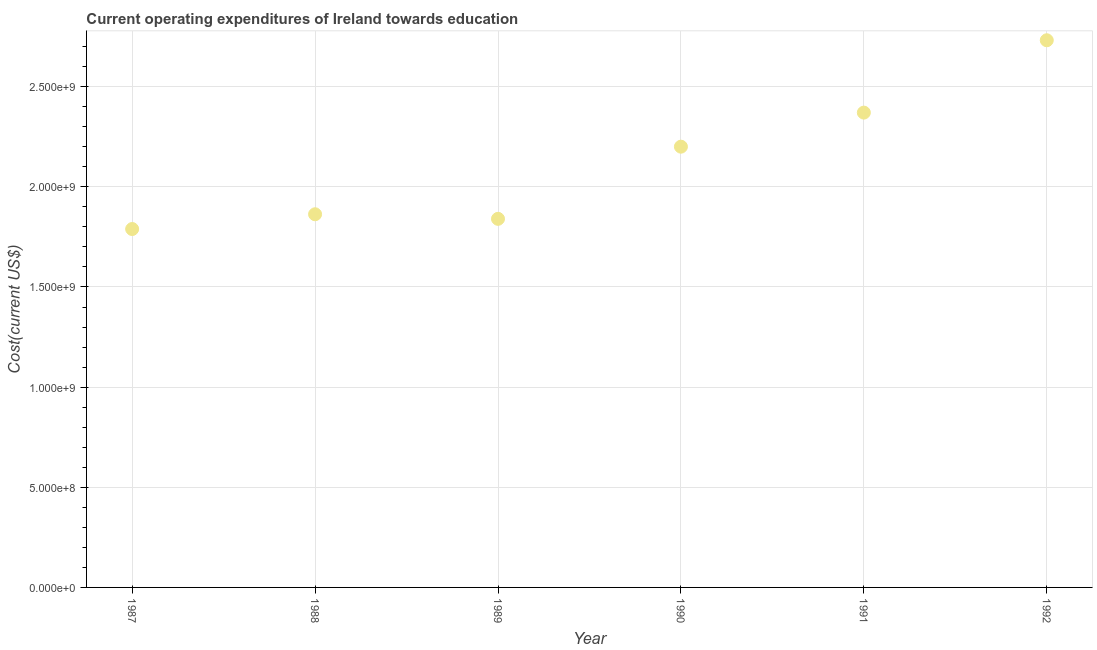What is the education expenditure in 1991?
Your response must be concise. 2.37e+09. Across all years, what is the maximum education expenditure?
Your response must be concise. 2.73e+09. Across all years, what is the minimum education expenditure?
Ensure brevity in your answer.  1.79e+09. In which year was the education expenditure maximum?
Your response must be concise. 1992. What is the sum of the education expenditure?
Ensure brevity in your answer.  1.28e+1. What is the difference between the education expenditure in 1989 and 1991?
Provide a short and direct response. -5.30e+08. What is the average education expenditure per year?
Make the answer very short. 2.13e+09. What is the median education expenditure?
Provide a short and direct response. 2.03e+09. In how many years, is the education expenditure greater than 600000000 US$?
Offer a terse response. 6. What is the ratio of the education expenditure in 1988 to that in 1989?
Offer a very short reply. 1.01. Is the education expenditure in 1991 less than that in 1992?
Your response must be concise. Yes. What is the difference between the highest and the second highest education expenditure?
Provide a short and direct response. 3.61e+08. Is the sum of the education expenditure in 1990 and 1992 greater than the maximum education expenditure across all years?
Ensure brevity in your answer.  Yes. What is the difference between the highest and the lowest education expenditure?
Your response must be concise. 9.42e+08. Does the education expenditure monotonically increase over the years?
Provide a succinct answer. No. What is the difference between two consecutive major ticks on the Y-axis?
Provide a short and direct response. 5.00e+08. Are the values on the major ticks of Y-axis written in scientific E-notation?
Your answer should be very brief. Yes. Does the graph contain grids?
Keep it short and to the point. Yes. What is the title of the graph?
Your response must be concise. Current operating expenditures of Ireland towards education. What is the label or title of the Y-axis?
Ensure brevity in your answer.  Cost(current US$). What is the Cost(current US$) in 1987?
Provide a succinct answer. 1.79e+09. What is the Cost(current US$) in 1988?
Ensure brevity in your answer.  1.86e+09. What is the Cost(current US$) in 1989?
Provide a succinct answer. 1.84e+09. What is the Cost(current US$) in 1990?
Your response must be concise. 2.20e+09. What is the Cost(current US$) in 1991?
Offer a terse response. 2.37e+09. What is the Cost(current US$) in 1992?
Offer a very short reply. 2.73e+09. What is the difference between the Cost(current US$) in 1987 and 1988?
Your answer should be compact. -7.37e+07. What is the difference between the Cost(current US$) in 1987 and 1989?
Your response must be concise. -5.09e+07. What is the difference between the Cost(current US$) in 1987 and 1990?
Give a very brief answer. -4.11e+08. What is the difference between the Cost(current US$) in 1987 and 1991?
Make the answer very short. -5.81e+08. What is the difference between the Cost(current US$) in 1987 and 1992?
Provide a succinct answer. -9.42e+08. What is the difference between the Cost(current US$) in 1988 and 1989?
Offer a terse response. 2.28e+07. What is the difference between the Cost(current US$) in 1988 and 1990?
Your answer should be compact. -3.37e+08. What is the difference between the Cost(current US$) in 1988 and 1991?
Provide a succinct answer. -5.08e+08. What is the difference between the Cost(current US$) in 1988 and 1992?
Provide a succinct answer. -8.69e+08. What is the difference between the Cost(current US$) in 1989 and 1990?
Offer a terse response. -3.60e+08. What is the difference between the Cost(current US$) in 1989 and 1991?
Your response must be concise. -5.30e+08. What is the difference between the Cost(current US$) in 1989 and 1992?
Give a very brief answer. -8.92e+08. What is the difference between the Cost(current US$) in 1990 and 1991?
Keep it short and to the point. -1.70e+08. What is the difference between the Cost(current US$) in 1990 and 1992?
Your answer should be compact. -5.31e+08. What is the difference between the Cost(current US$) in 1991 and 1992?
Your answer should be compact. -3.61e+08. What is the ratio of the Cost(current US$) in 1987 to that in 1990?
Make the answer very short. 0.81. What is the ratio of the Cost(current US$) in 1987 to that in 1991?
Offer a terse response. 0.76. What is the ratio of the Cost(current US$) in 1987 to that in 1992?
Make the answer very short. 0.66. What is the ratio of the Cost(current US$) in 1988 to that in 1990?
Provide a short and direct response. 0.85. What is the ratio of the Cost(current US$) in 1988 to that in 1991?
Give a very brief answer. 0.79. What is the ratio of the Cost(current US$) in 1988 to that in 1992?
Offer a very short reply. 0.68. What is the ratio of the Cost(current US$) in 1989 to that in 1990?
Give a very brief answer. 0.84. What is the ratio of the Cost(current US$) in 1989 to that in 1991?
Provide a succinct answer. 0.78. What is the ratio of the Cost(current US$) in 1989 to that in 1992?
Ensure brevity in your answer.  0.67. What is the ratio of the Cost(current US$) in 1990 to that in 1991?
Give a very brief answer. 0.93. What is the ratio of the Cost(current US$) in 1990 to that in 1992?
Your answer should be compact. 0.81. What is the ratio of the Cost(current US$) in 1991 to that in 1992?
Provide a succinct answer. 0.87. 